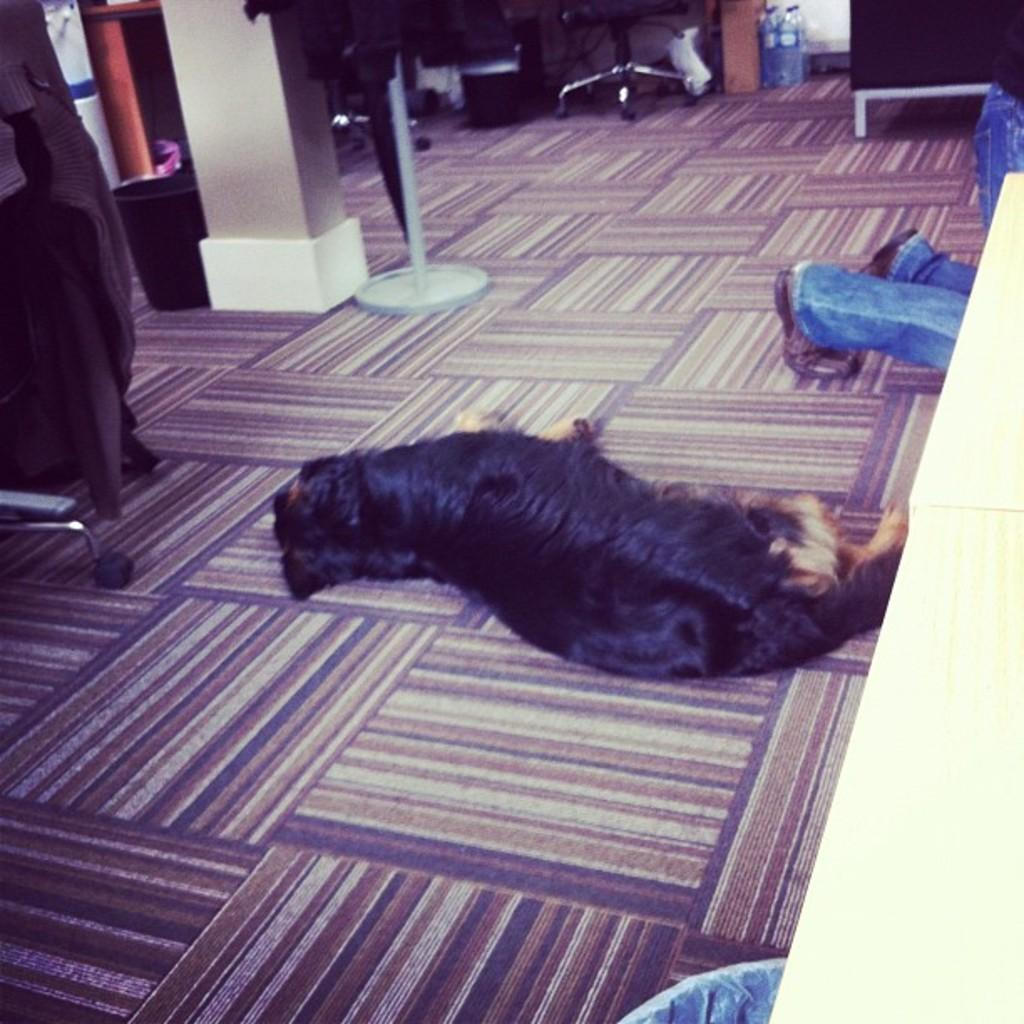What animal can be seen on the floor in the image? There is a dog on the floor in the image. What vertical structure is present in the image? There is a pole in the image. What type of furniture is in the image? There is a chair in the image. What object is used for holding waste in the image? There is a bin in the image. What architectural feature can be seen in the image? There is a pillar in the image. What type of container is present in the image? There are bottles in the image. What type of writing can be seen on the dog's collar in the image? There is no writing visible on the dog's collar in the image. What is the value of the chair in the image? The value of the chair cannot be determined from the image alone. How many bushes are present in the image? There are no bushes present in the image. 